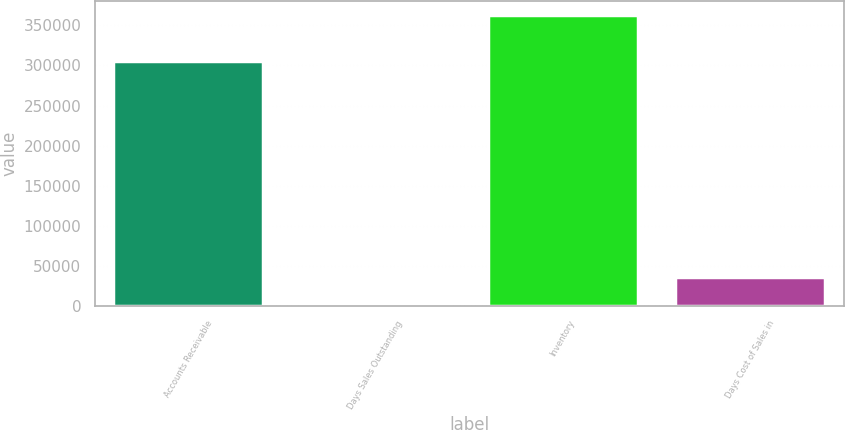<chart> <loc_0><loc_0><loc_500><loc_500><bar_chart><fcel>Accounts Receivable<fcel>Days Sales Outstanding<fcel>Inventory<fcel>Days Cost of Sales in<nl><fcel>305761<fcel>46<fcel>362945<fcel>36335.9<nl></chart> 